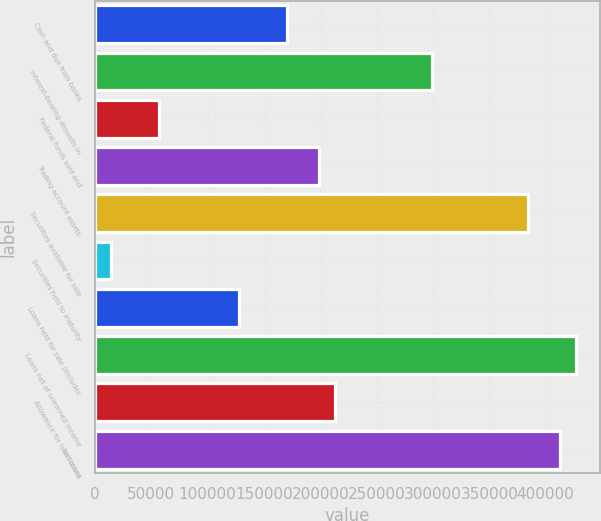Convert chart to OTSL. <chart><loc_0><loc_0><loc_500><loc_500><bar_chart><fcel>Cash and due from banks<fcel>Interest-bearing deposits in<fcel>Federal funds sold and<fcel>Trading account assets<fcel>Securities available for sale<fcel>Securities held to maturity<fcel>Loans held for sale (includes<fcel>Loans net of unearned income<fcel>Allowance for loan losses<fcel>Net loans<nl><fcel>170779<fcel>298855<fcel>56934.4<fcel>199240<fcel>384238<fcel>14242.6<fcel>128087<fcel>426930<fcel>213471<fcel>412699<nl></chart> 